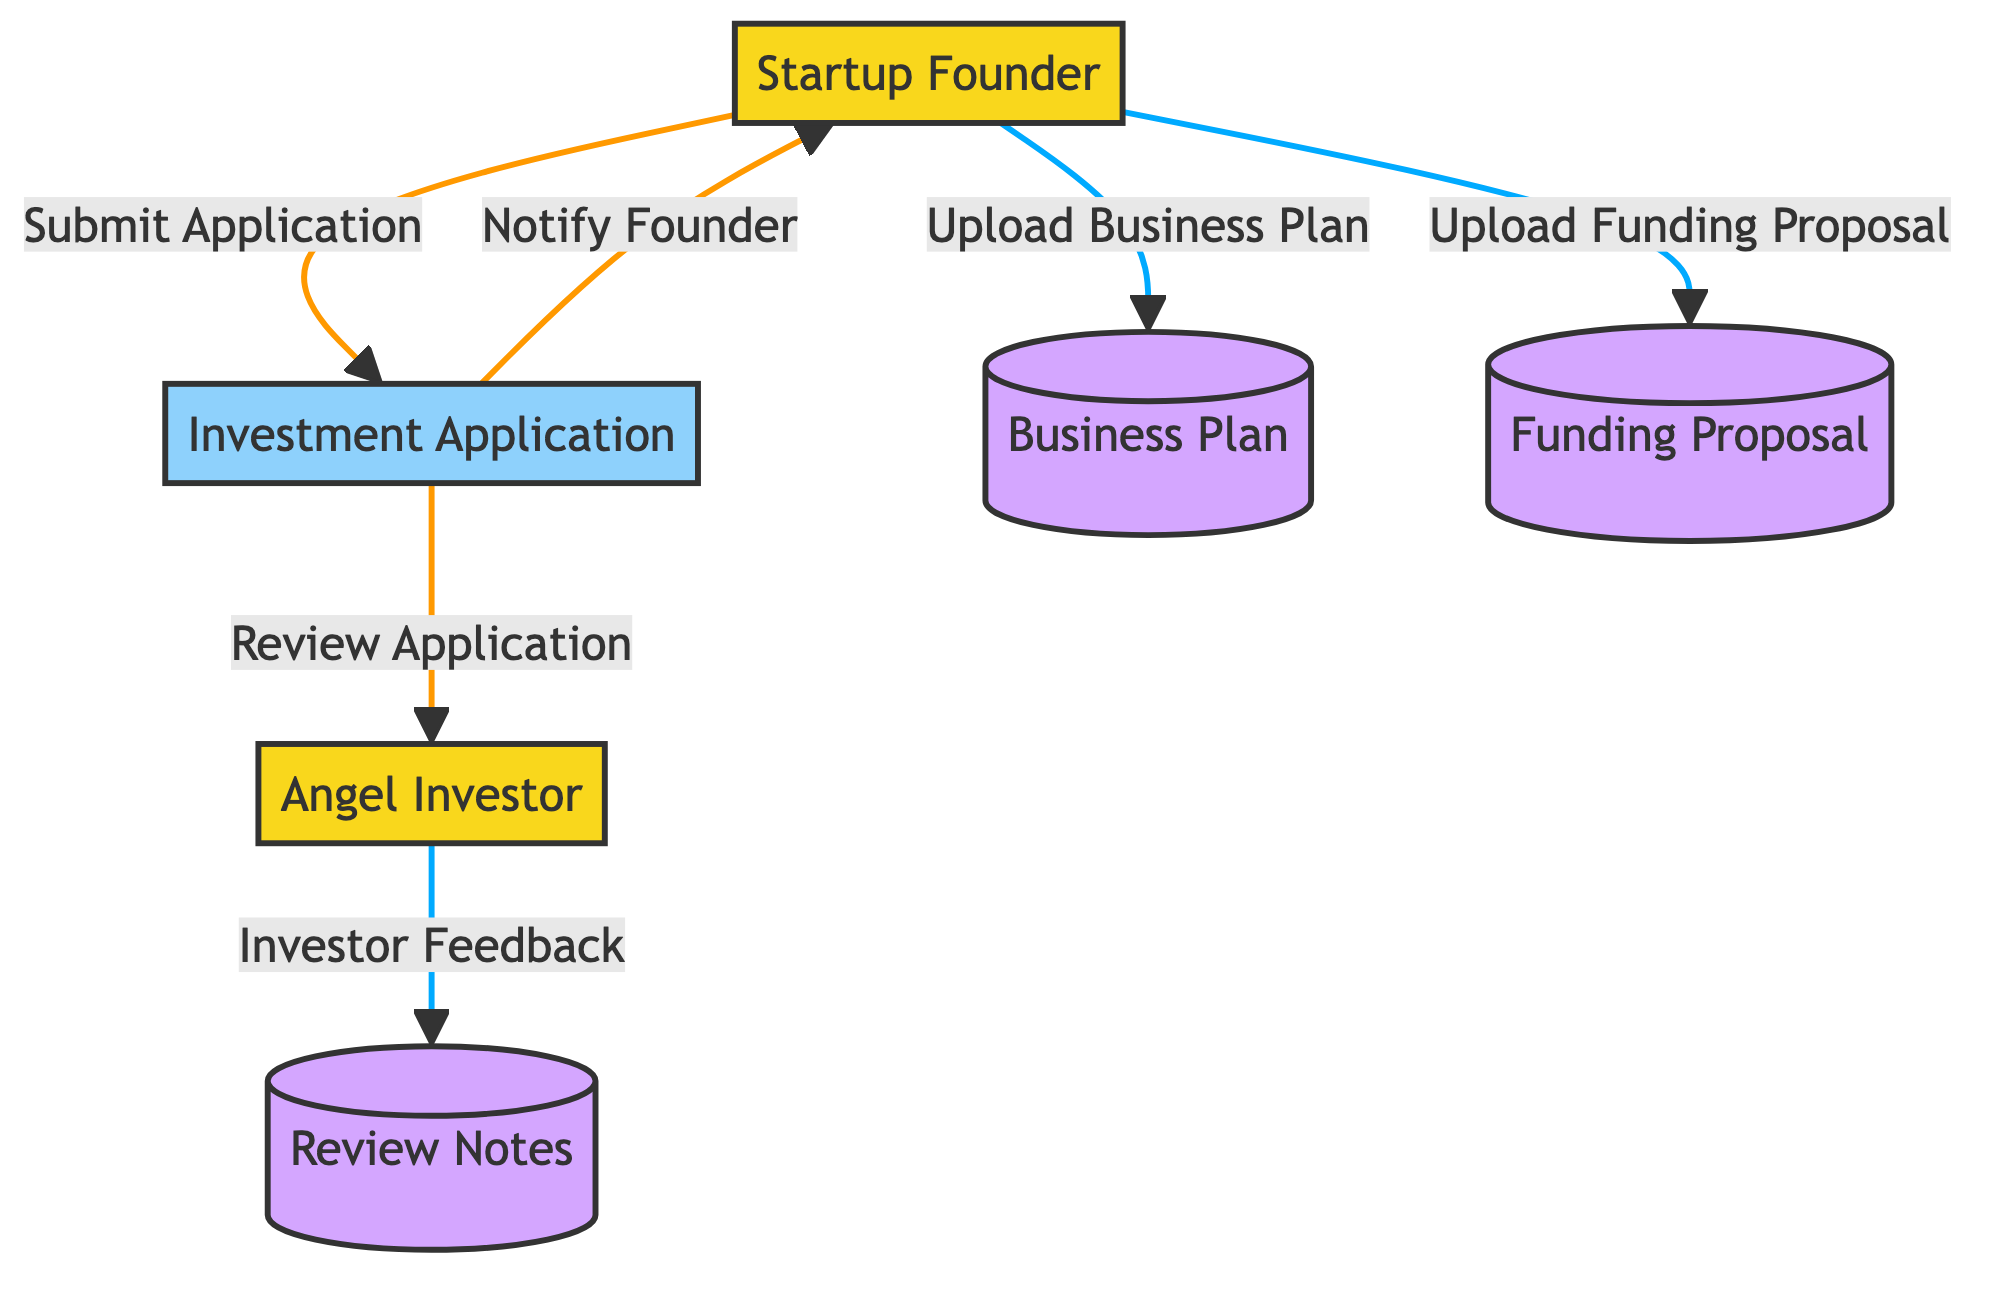What is the total number of entities in the diagram? There are two external entities in the diagram: the Angel Investor and the Startup Founder.
Answer: 2 What is the process that handles the submission and review of funding applications? The process labeled Investment Application manages the submission and review of funding applications, as indicated in the diagram.
Answer: Investment Application Which external entity submits the funding application? The diagram shows that the Startup Founder is the entity responsible for submitting the funding application.
Answer: Startup Founder What data store contains the startup's business model and growth plans? The data store named Business Plan contains detailed descriptions of the startup's business model and growth plans as per the diagram details.
Answer: Business Plan What flow indicates the feedback from the angel investor? The arrow labeled Investor Feedback indicates the flow of feedback from the Angel Investor to the Review Notes.
Answer: Investor Feedback After reviewing the application, which external entity is notified of the review status? The flow labeled Notify Founder indicates that the Startup Founder is notified of the review status and feedback after the application review.
Answer: Startup Founder How many processes are present in the diagram? The diagram contains one process, which is the Investment Application pertaining to the workflow.
Answer: 1 What is the relationship between the Startup Founder and the Investment Application? The Startup Founder submits the application to the Investment Application process, establishing a direct relationship between them according to the flow indicated in the diagram.
Answer: Submit Application Which data store holds the notes and feedback from the angel investor? The Review Notes data store contains the notes and feedback from the Angel Investor after reviewing the application, as specified in the diagram.
Answer: Review Notes How many data stores are included in the diagram? The diagram includes three data stores: Business Plan, Funding Proposal, and Review Notes, covering various aspects of the investment workflow.
Answer: 3 